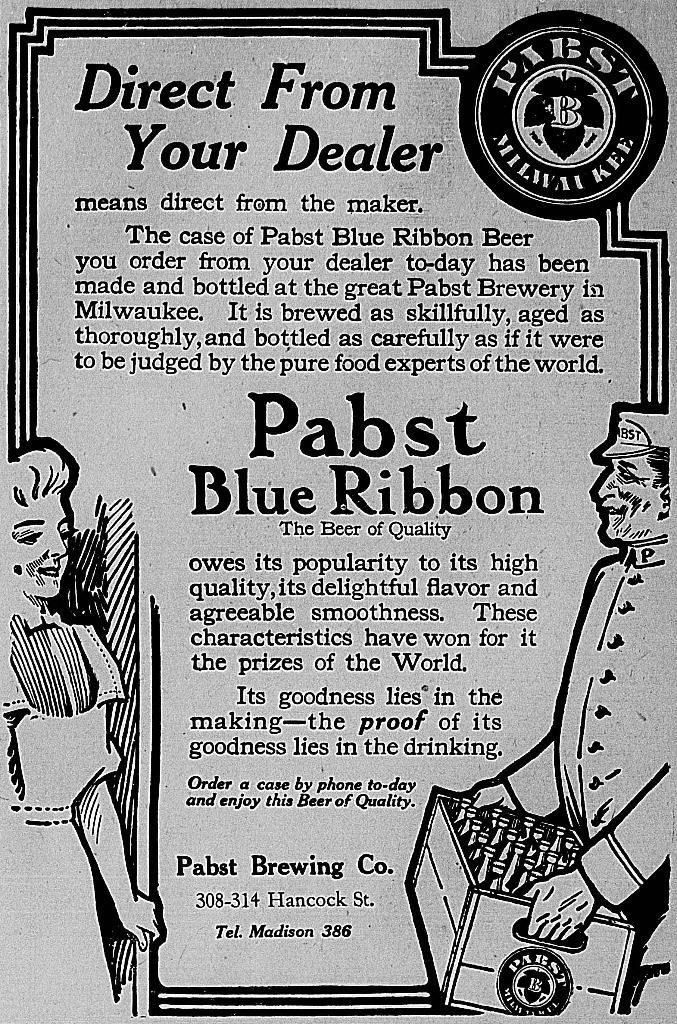What can be seen in the image related to advertising or information? There is a poster in the image. What is featured on the poster? There is text on the poster. What is the taste of the zinc pump in the image? There is no zinc pump present in the image, and therefore no taste can be associated with it. 